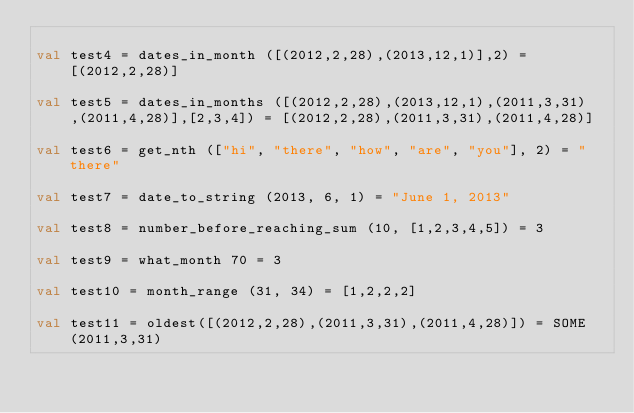<code> <loc_0><loc_0><loc_500><loc_500><_SML_>
val test4 = dates_in_month ([(2012,2,28),(2013,12,1)],2) = [(2012,2,28)]

val test5 = dates_in_months ([(2012,2,28),(2013,12,1),(2011,3,31),(2011,4,28)],[2,3,4]) = [(2012,2,28),(2011,3,31),(2011,4,28)]

val test6 = get_nth (["hi", "there", "how", "are", "you"], 2) = "there"

val test7 = date_to_string (2013, 6, 1) = "June 1, 2013"

val test8 = number_before_reaching_sum (10, [1,2,3,4,5]) = 3

val test9 = what_month 70 = 3

val test10 = month_range (31, 34) = [1,2,2,2]

val test11 = oldest([(2012,2,28),(2011,3,31),(2011,4,28)]) = SOME (2011,3,31)</code> 